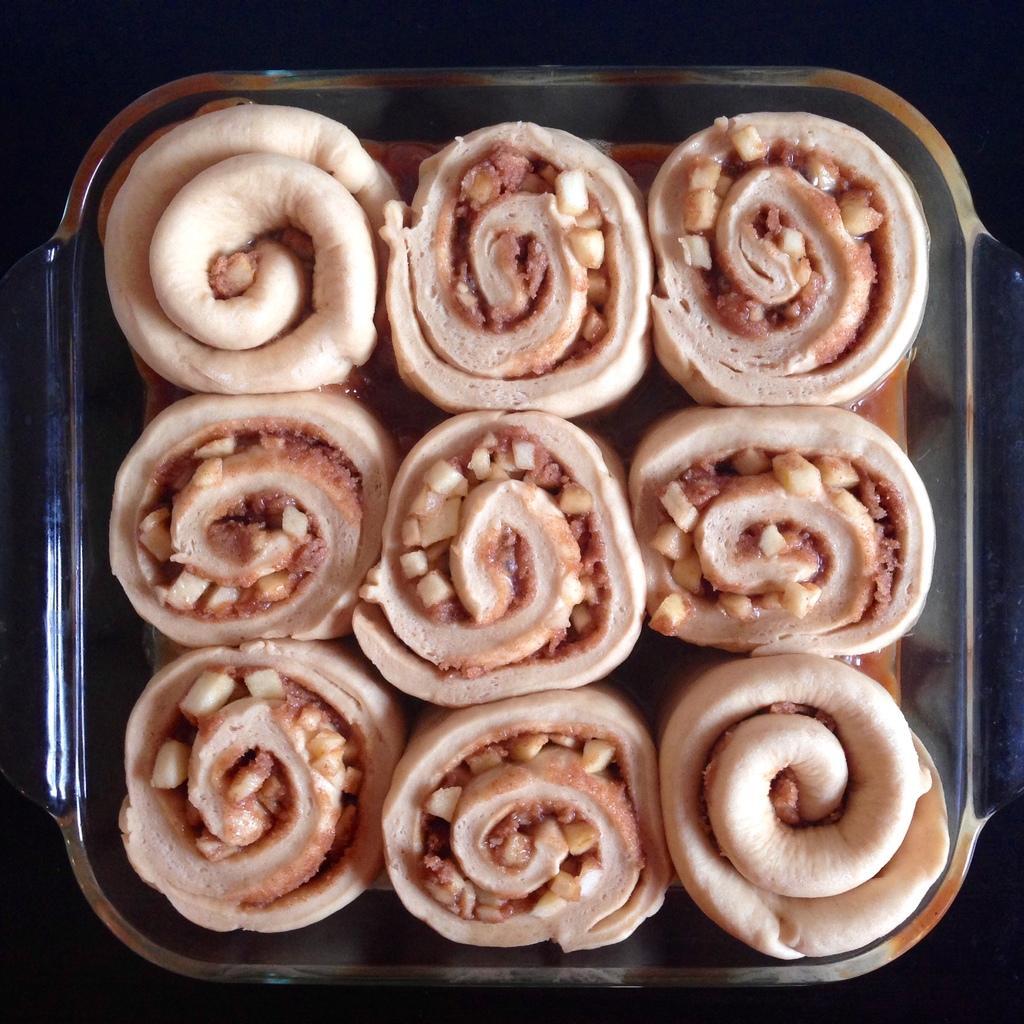In one or two sentences, can you explain what this image depicts? In the center of the image we can see rolls placed in bowl. 